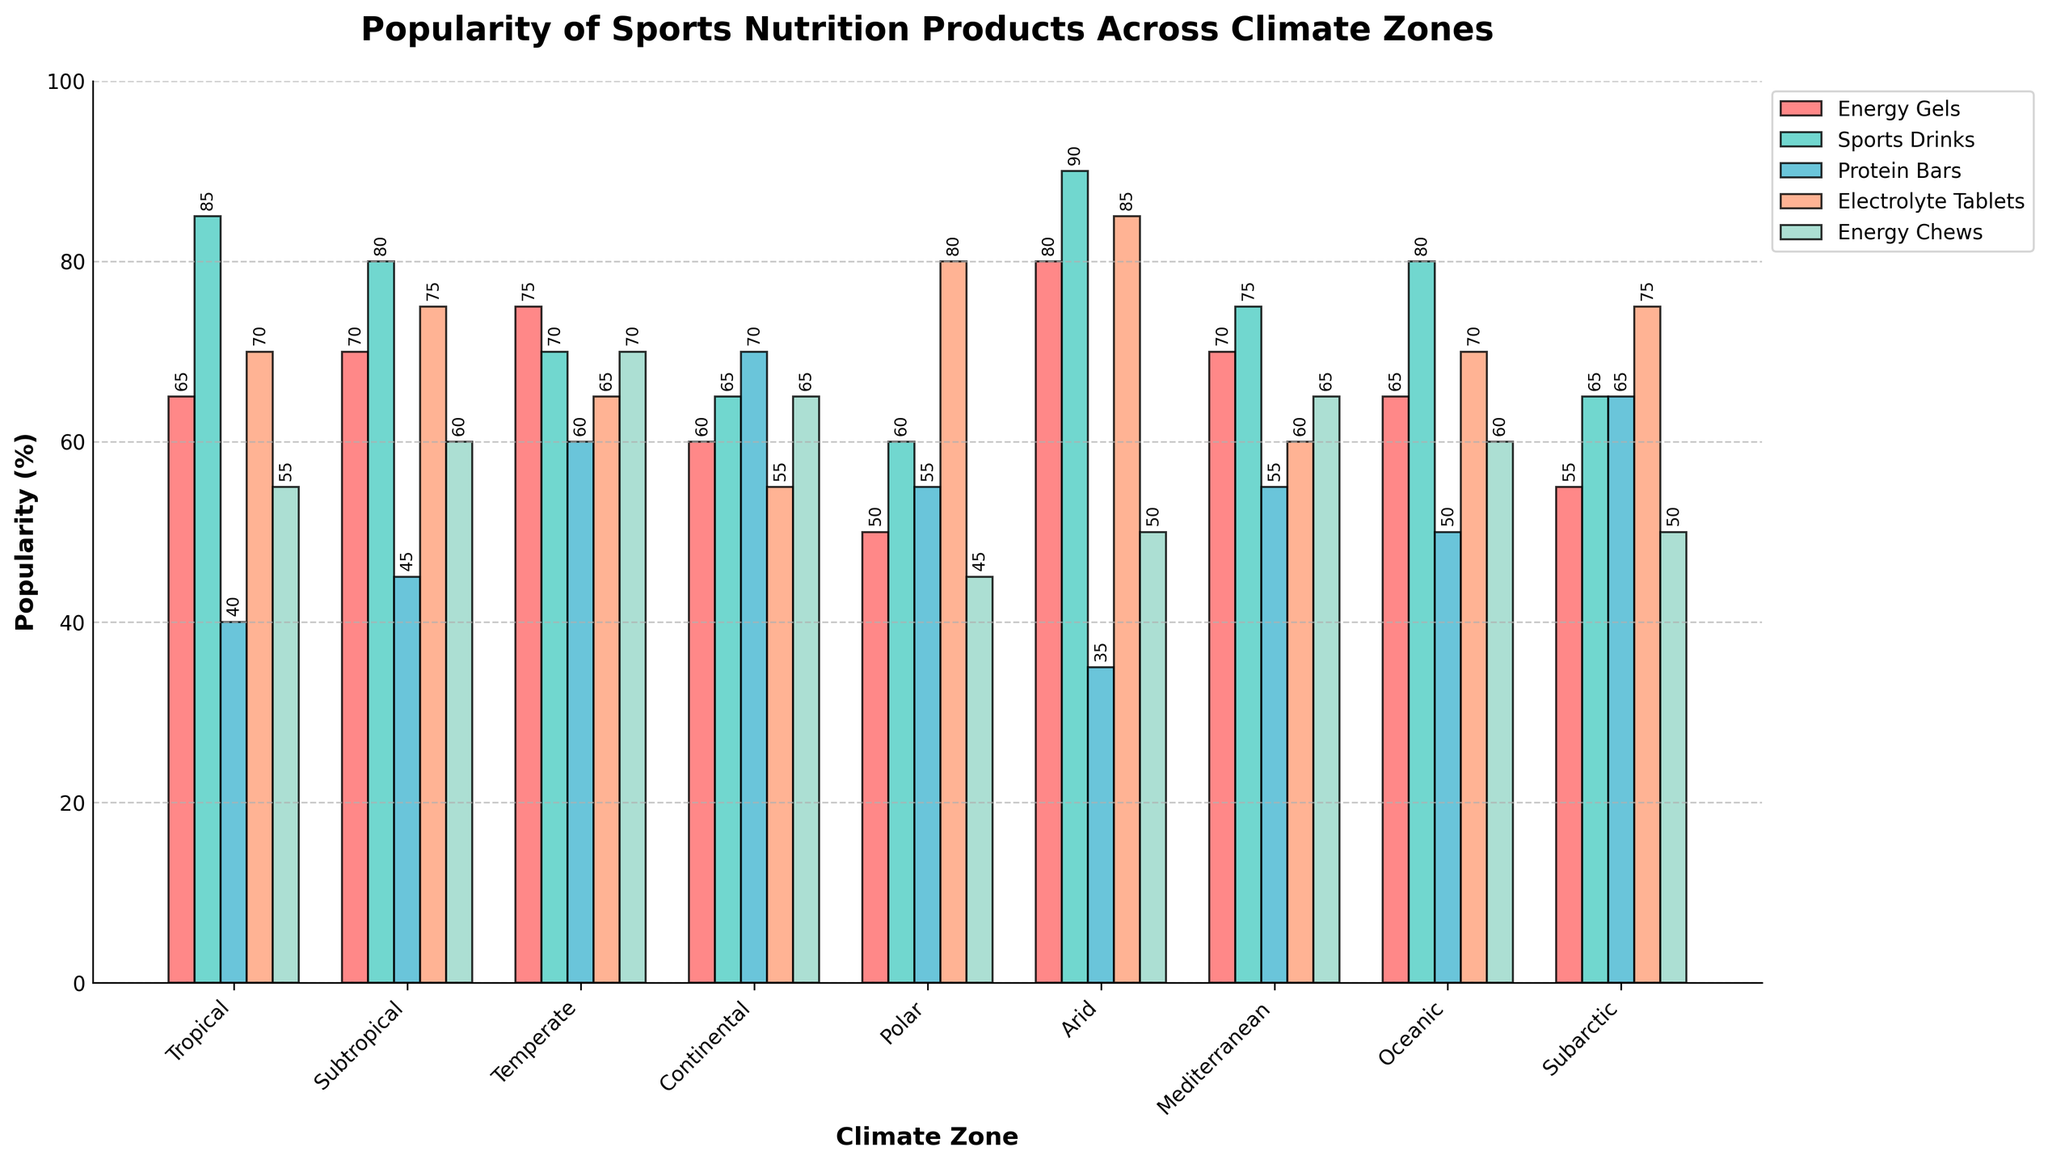Which climate zone has the highest popularity for sports drinks? By examining the height of the bars for sports drinks (represented by a specific color, like green), the Mediterranean zone appears to have the highest bar for Sports Drinks.
Answer: Arid Which sports nutrition product is least popular in the continental climate zone? Look at the Continental climate zone and compare the height of all the bars pertaining to different products. The shortest bar represents the least popular product.
Answer: Electrolyte Tablets What's the total popularity of sports drinks across all climate zones? Sum the popularity percentages of Sports Drinks from each climate zone: 85 + 80 + 70 + 65 + 60 + 90 + 75 + 80 + 65. The total is 670.
Answer: 670 Which climate zone has the least variation in the popularity of different products? Least variation implies that all bars are relatively similar in height. By comparing the bar heights for all products in each climate zone visually, Subarctic has the least variation.
Answer: Subarctic For the temperate climate zone, what's the difference in popularity between protein bars and electrolyte tablets? Locate the bars for Protein Bars and Electrolyte Tablets in the Temperate zone and subtract the shorter bar's height from the taller bar's height: 60 (Protein Bars) - 65 (Electrolyte Tablets). The difference is 5.
Answer: 5 Which product in the tropical climate zone is more popular than energy chews but less popular than sports drinks? Look at the Tropical climate zone and compare the heights of bars. A bar taller than Energy Chews but shorter than Sports Drinks points to Energy Gels.
Answer: Energy Gels In which climate zone is the popularity of electrolyte tablets the highest? Identify the tallest bar for Electrolyte Tablets among all climate zones. The highest point is in the Polar climate zone.
Answer: Polar What's the average popularity of energy gels across all climate zones? Average the popularity of Energy Gels across climate zones by summing the values: (65 + 70 + 75 + 60 + 50 + 80 + 70 + 65 + 55) and then dividing by the number of zones (9). The average is 63.9
Answer: 63.9 In the polar climate zone, how much more popular are electrolyte tablets compared to protein bars? Look at the Polar climate zone and subtract the height of the Protein Bars bar from the height of the Electrolyte Tablets bar: 80 - 55. The difference is 25.
Answer: 25 